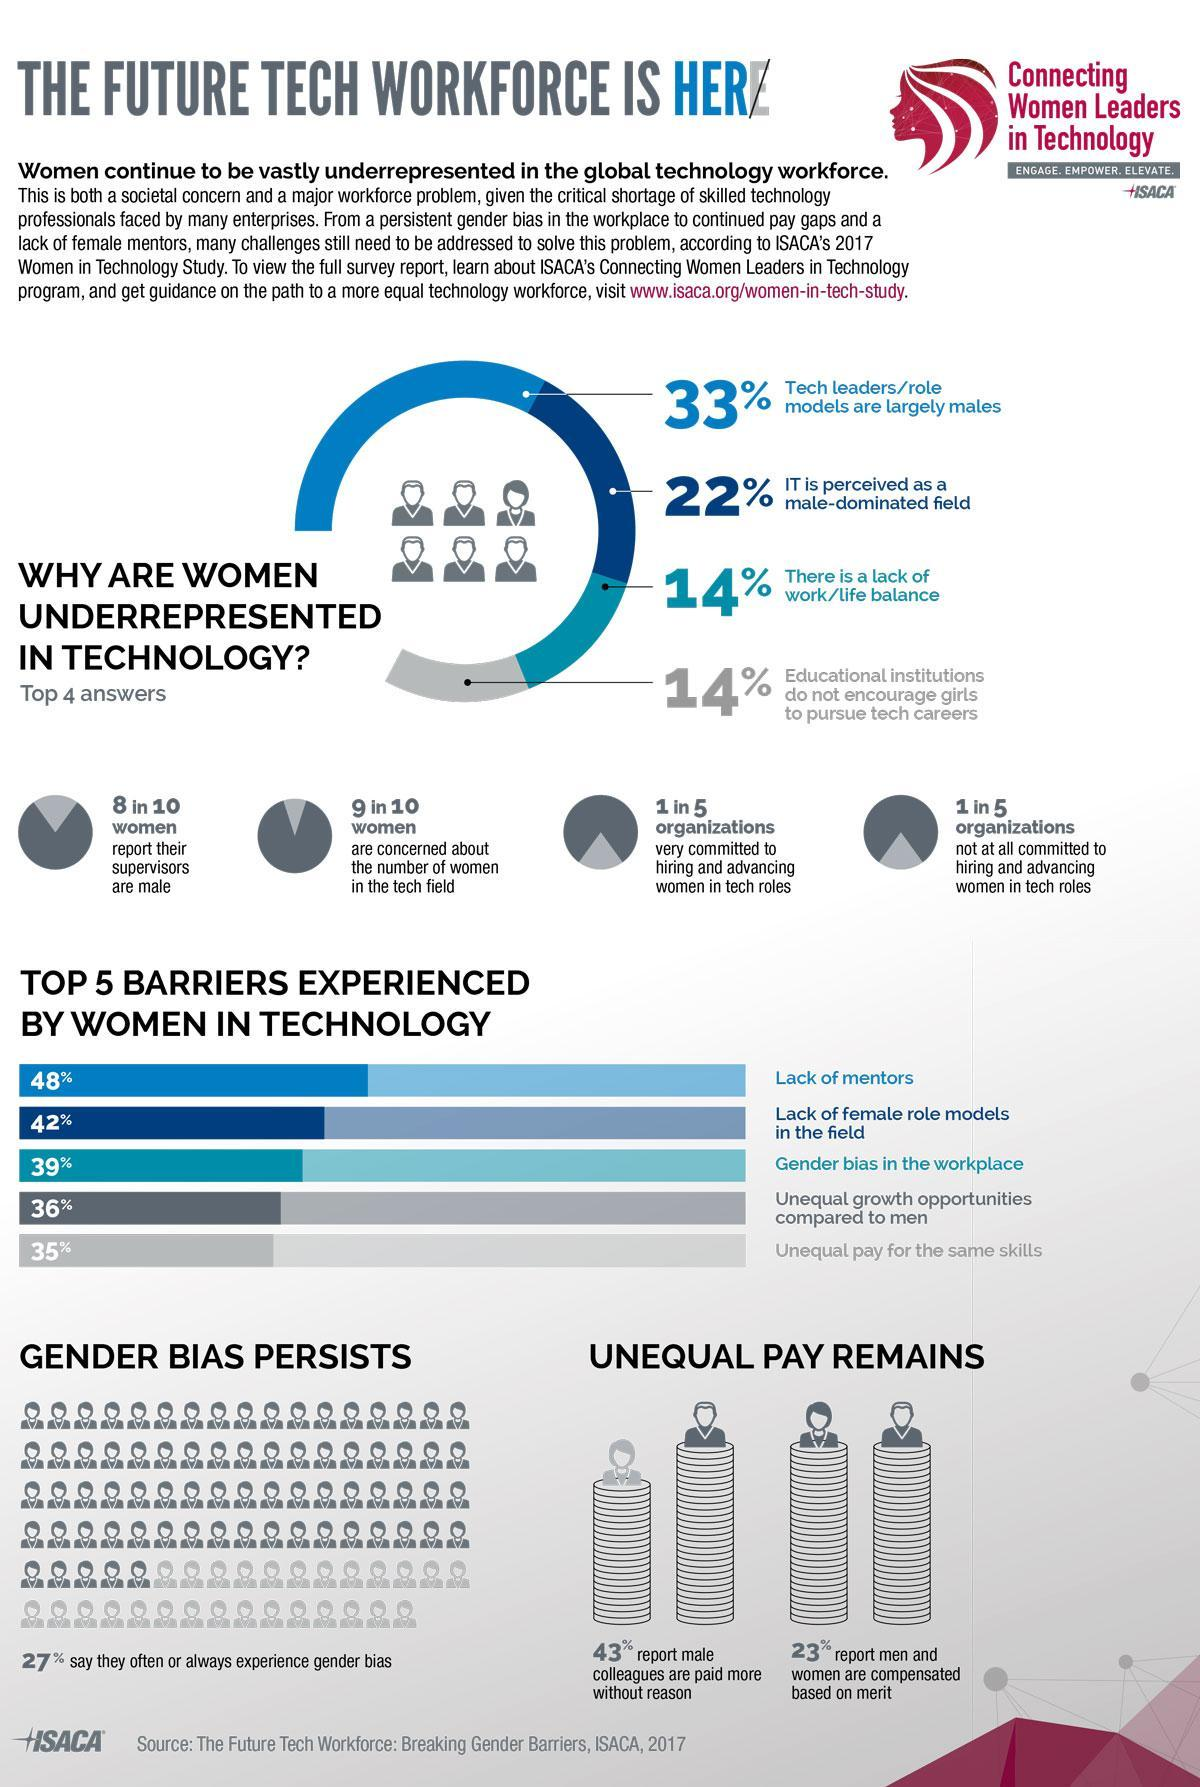How many women are concerned about the number of ladies in the tech field?
Answer the question with a short phrase. 9 in 10 How many of the women feel that men are paid more without reason? 43% How many of the females report their supervisors are male? 8 in 10 